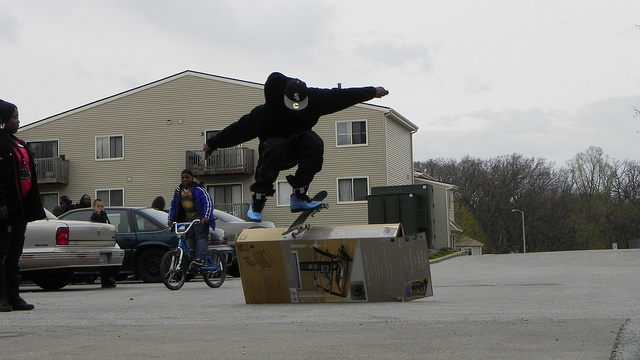Describe the objects in this image and their specific colors. I can see people in lightgray, black, gray, and navy tones, people in lightgray, black, maroon, gray, and brown tones, car in lightgray, gray, black, darkgray, and maroon tones, car in lightgray, black, gray, purple, and darkgray tones, and people in lightgray, black, navy, and gray tones in this image. 